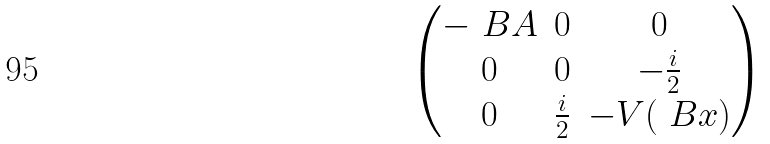Convert formula to latex. <formula><loc_0><loc_0><loc_500><loc_500>\begin{pmatrix} - \ B A & 0 & 0 \\ 0 & 0 & - \frac { i } { 2 } \\ 0 & \frac { i } { 2 } & - V ( \ B x ) \end{pmatrix}</formula> 